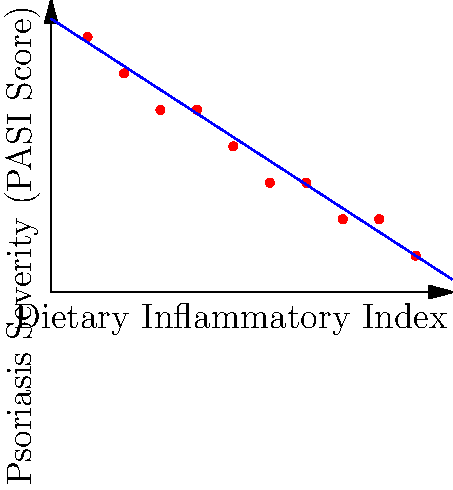Based on the scatter plot showing the relationship between Dietary Inflammatory Index and Psoriasis Severity (PASI Score), what can be inferred about the correlation between dietary choices and psoriasis symptoms? To answer this question, let's analyze the scatter plot step-by-step:

1. Observe the x-axis: It represents the Dietary Inflammatory Index, which likely measures how inflammatory a person's diet is. Lower values indicate less inflammatory diets, while higher values indicate more inflammatory diets.

2. Observe the y-axis: It represents the Psoriasis Severity using the PASI (Psoriasis Area and Severity Index) Score. Higher scores indicate more severe psoriasis symptoms.

3. Examine the data points: As we move from left to right (increasing Dietary Inflammatory Index), we can see that the corresponding PASI Scores tend to decrease.

4. Notice the blue line: This is likely a best-fit line or trend line, which helps visualize the overall relationship between the two variables.

5. Analyze the trend: The downward slope of the blue line indicates a negative correlation between the Dietary Inflammatory Index and Psoriasis Severity.

6. Interpret the correlation: This negative correlation suggests that as the Dietary Inflammatory Index increases (more inflammatory diet), the Psoriasis Severity tends to decrease.

7. Consider the implications: This unexpected relationship might indicate that individuals with more severe psoriasis are more likely to adopt less inflammatory diets as a management strategy, rather than suggesting that inflammatory diets improve psoriasis symptoms.

Given this analysis, we can infer that there is a negative correlation between dietary inflammatory index and psoriasis severity, but this likely reflects adaptive behavior rather than a causal relationship.
Answer: Negative correlation, possibly due to adaptive dietary changes in response to symptom severity. 